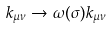<formula> <loc_0><loc_0><loc_500><loc_500>k _ { \mu \nu } \to \omega ( \sigma ) k _ { \mu \nu }</formula> 